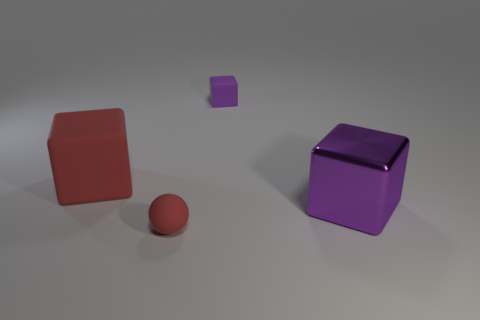Add 3 red balls. How many objects exist? 7 Subtract all spheres. How many objects are left? 3 Subtract all large metallic things. Subtract all large rubber blocks. How many objects are left? 2 Add 1 small purple matte objects. How many small purple matte objects are left? 2 Add 2 big blue cubes. How many big blue cubes exist? 2 Subtract 0 blue cylinders. How many objects are left? 4 